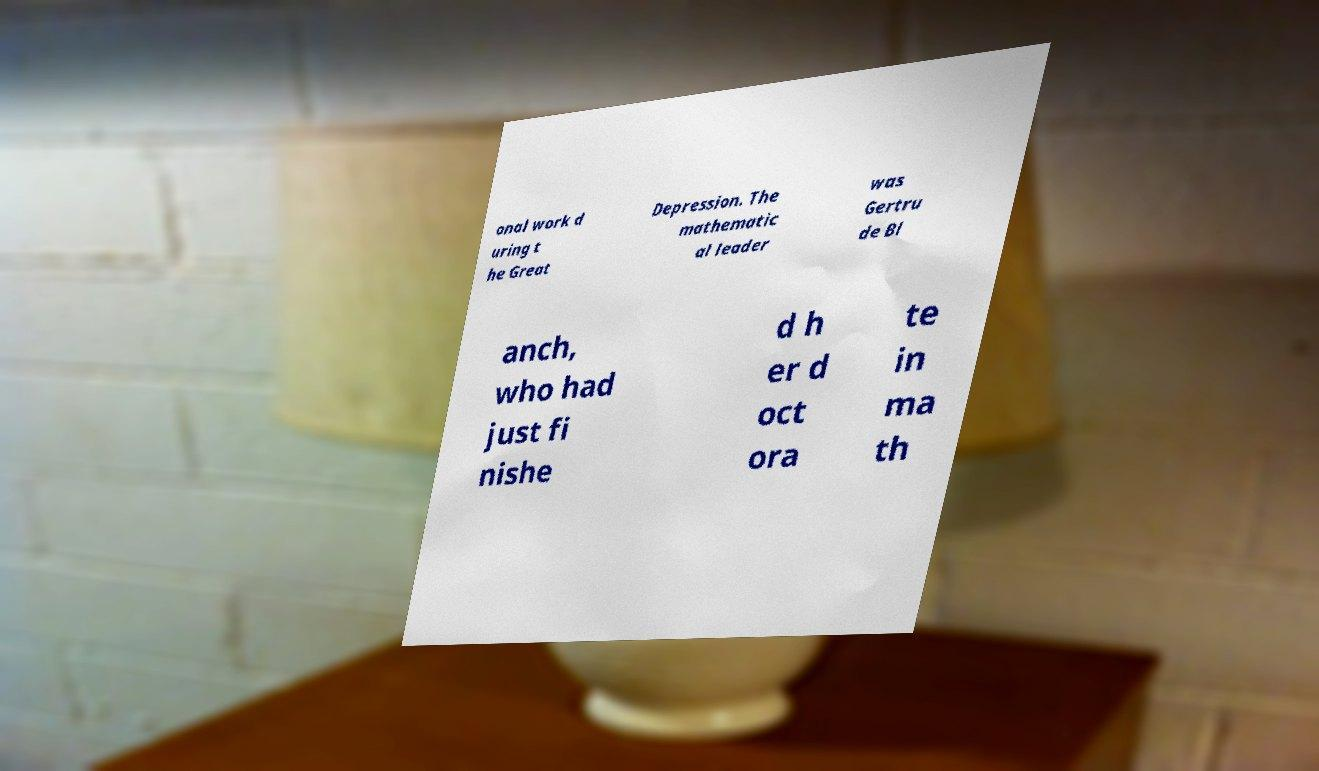For documentation purposes, I need the text within this image transcribed. Could you provide that? onal work d uring t he Great Depression. The mathematic al leader was Gertru de Bl anch, who had just fi nishe d h er d oct ora te in ma th 